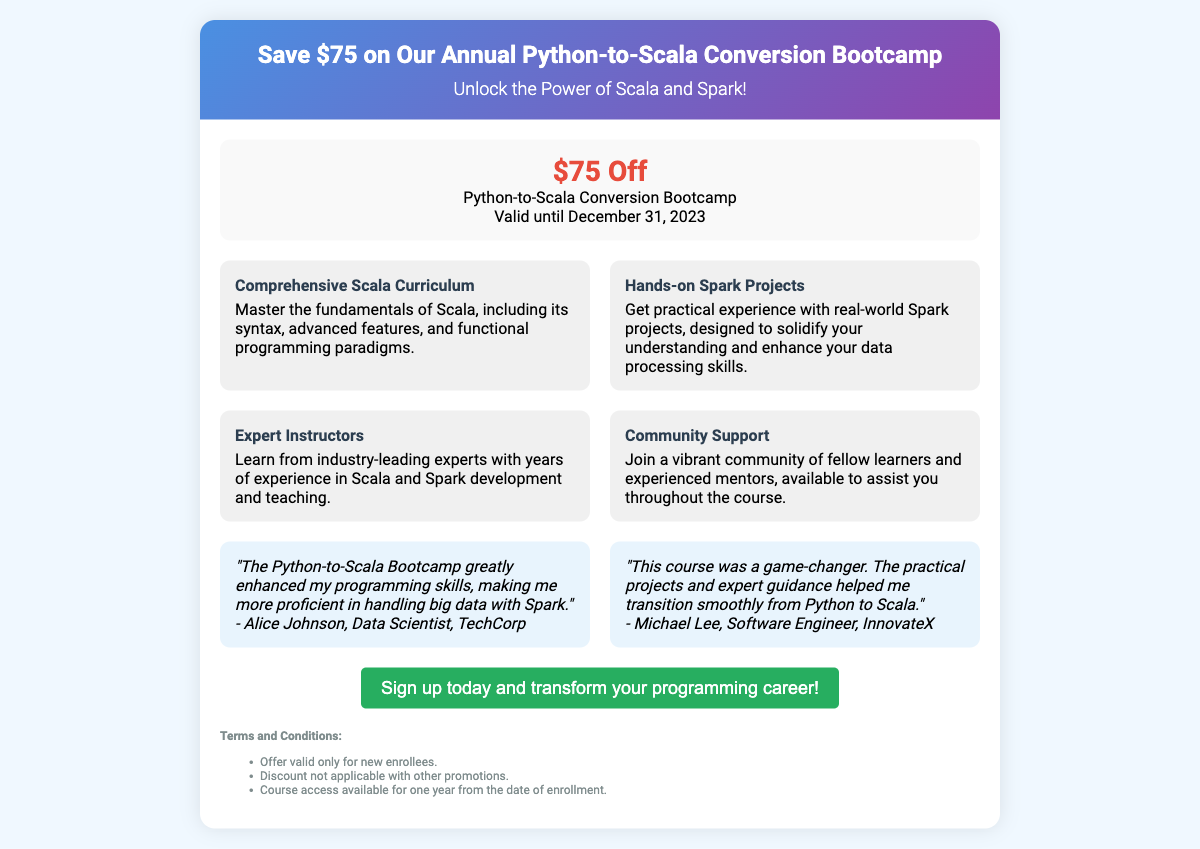What is the discount amount? The discount amount mentioned in the document is a specific value indicated within the offer details.
Answer: $75 When does the offer expire? The expiration date for the offer is clearly stated in the document's offer section.
Answer: December 31, 2023 What is one benefit of the course? The document lists specific benefits under the features section, providing insights into what learners can expect.
Answer: Comprehensive Scala Curriculum Who is a testimonial from? The testimonials section includes quotes from participants, indicating their names and occupations for credibility.
Answer: Alice Johnson What is the course focused on? The document highlights the central theme and content covered in the course title and features.
Answer: Scala and Spark Are the courses available for a limited time? The terms section specifies if there are any restrictions regarding course access after enrollment.
Answer: Yes What type of support is offered? The features section describes community resources available to students during the course.
Answer: Community Support Is the discount applicable with other promotions? The terms and conditions state whether the discount can be combined with other offers.
Answer: No 